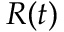<formula> <loc_0><loc_0><loc_500><loc_500>R ( t )</formula> 